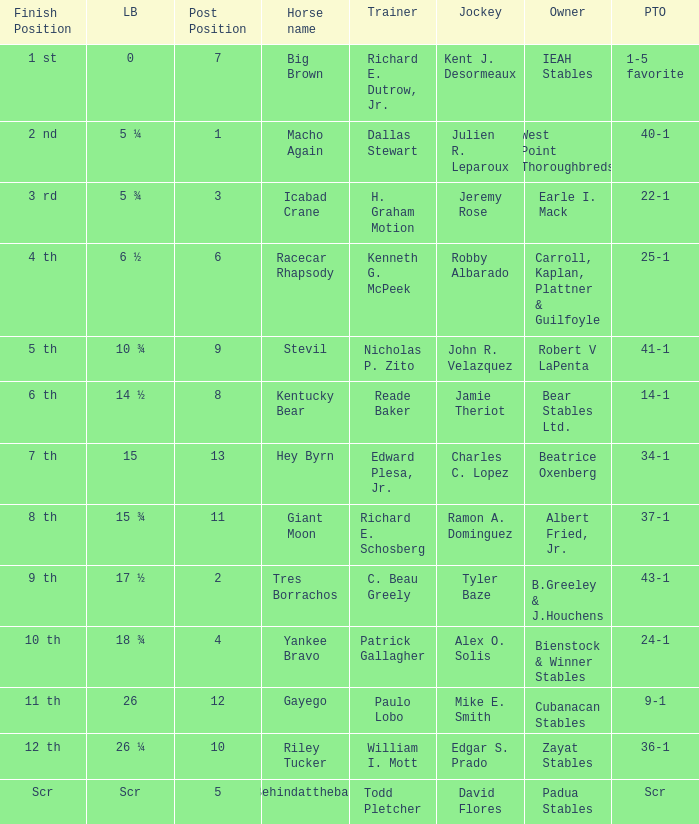What's the post position when the lengths behind is 0? 7.0. 